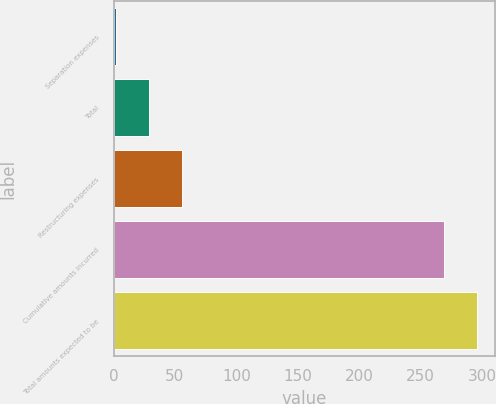Convert chart. <chart><loc_0><loc_0><loc_500><loc_500><bar_chart><fcel>Separation expenses<fcel>Total<fcel>Restructuring expenses<fcel>Cumulative amounts incurred<fcel>Total amounts expected to be<nl><fcel>2<fcel>28.7<fcel>55.4<fcel>269<fcel>295.7<nl></chart> 